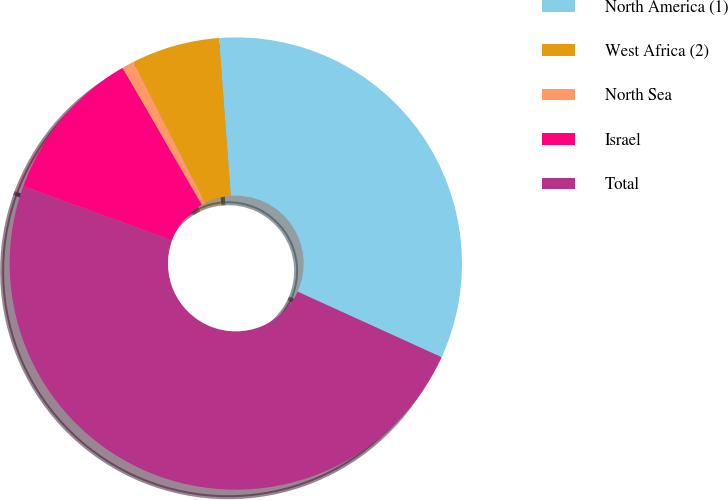Convert chart to OTSL. <chart><loc_0><loc_0><loc_500><loc_500><pie_chart><fcel>North America (1)<fcel>West Africa (2)<fcel>North Sea<fcel>Israel<fcel>Total<nl><fcel>32.99%<fcel>6.29%<fcel>0.89%<fcel>11.08%<fcel>48.75%<nl></chart> 